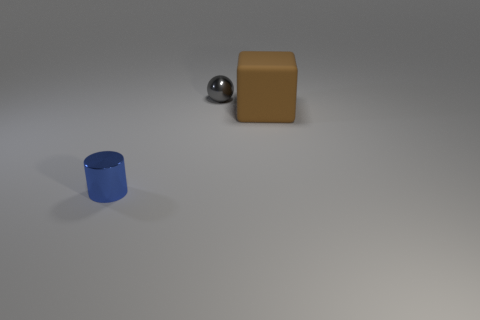Add 3 brown blocks. How many objects exist? 6 Subtract all cylinders. How many objects are left? 2 Subtract 0 purple cylinders. How many objects are left? 3 Subtract all small brown shiny things. Subtract all big objects. How many objects are left? 2 Add 2 tiny gray shiny balls. How many tiny gray shiny balls are left? 3 Add 1 blue metal blocks. How many blue metal blocks exist? 1 